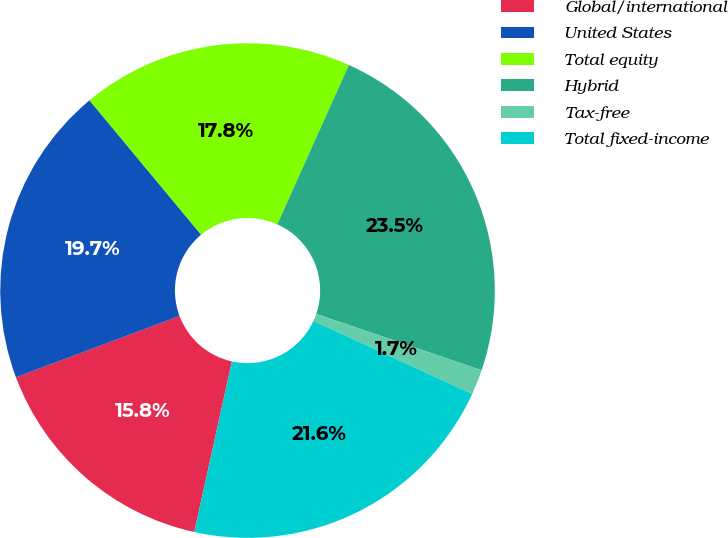<chart> <loc_0><loc_0><loc_500><loc_500><pie_chart><fcel>Global/international<fcel>United States<fcel>Total equity<fcel>Hybrid<fcel>Tax-free<fcel>Total fixed-income<nl><fcel>15.84%<fcel>19.67%<fcel>17.75%<fcel>23.5%<fcel>1.65%<fcel>21.58%<nl></chart> 